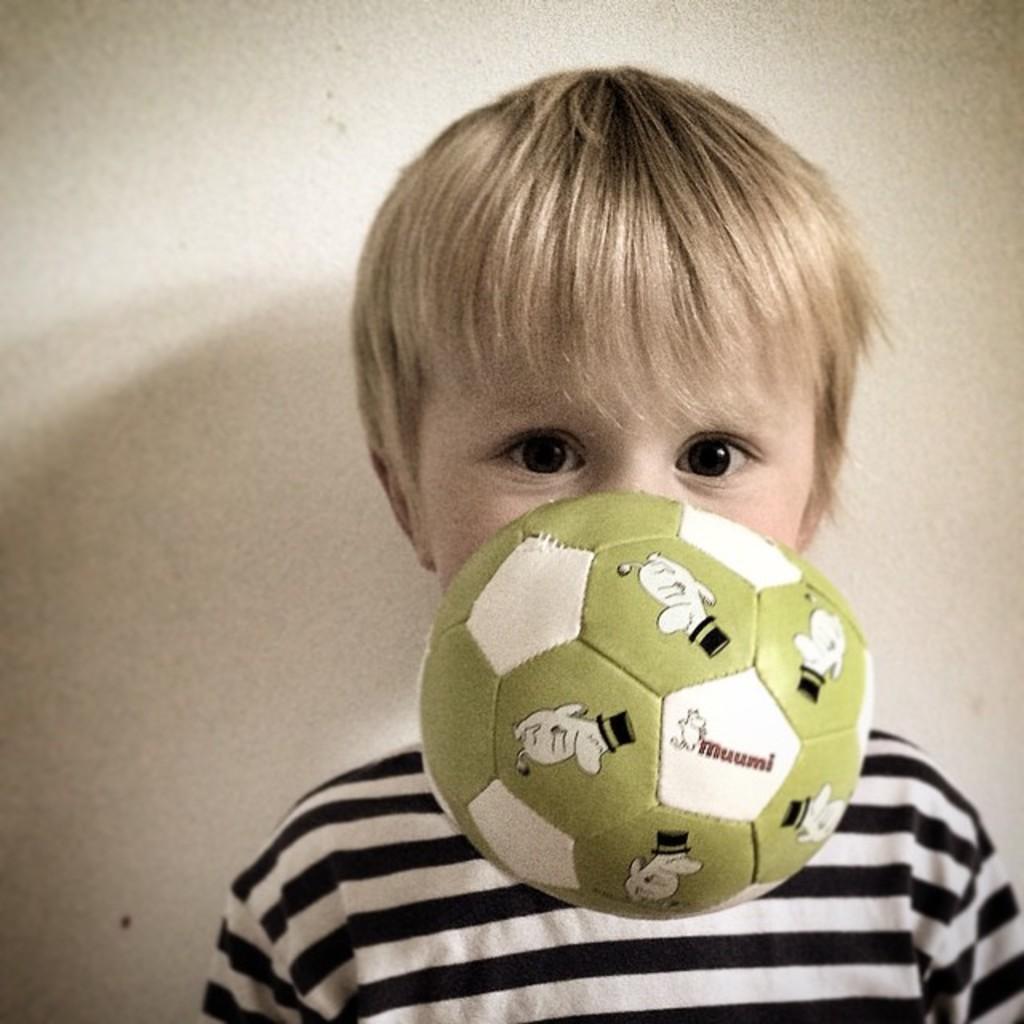Please provide a concise description of this image. In this picture I can see a boy, he is wearing a t-shirt, there is a football in the middle. 